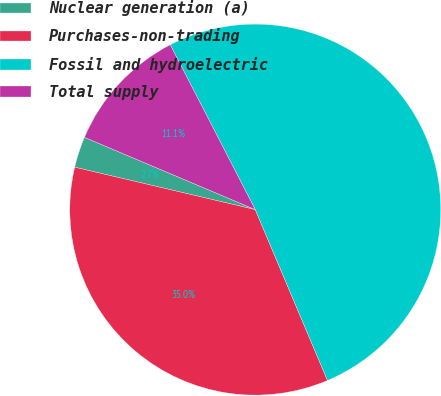<chart> <loc_0><loc_0><loc_500><loc_500><pie_chart><fcel>Nuclear generation (a)<fcel>Purchases-non-trading<fcel>Fossil and hydroelectric<fcel>Total supply<nl><fcel>2.7%<fcel>35.04%<fcel>51.21%<fcel>11.05%<nl></chart> 